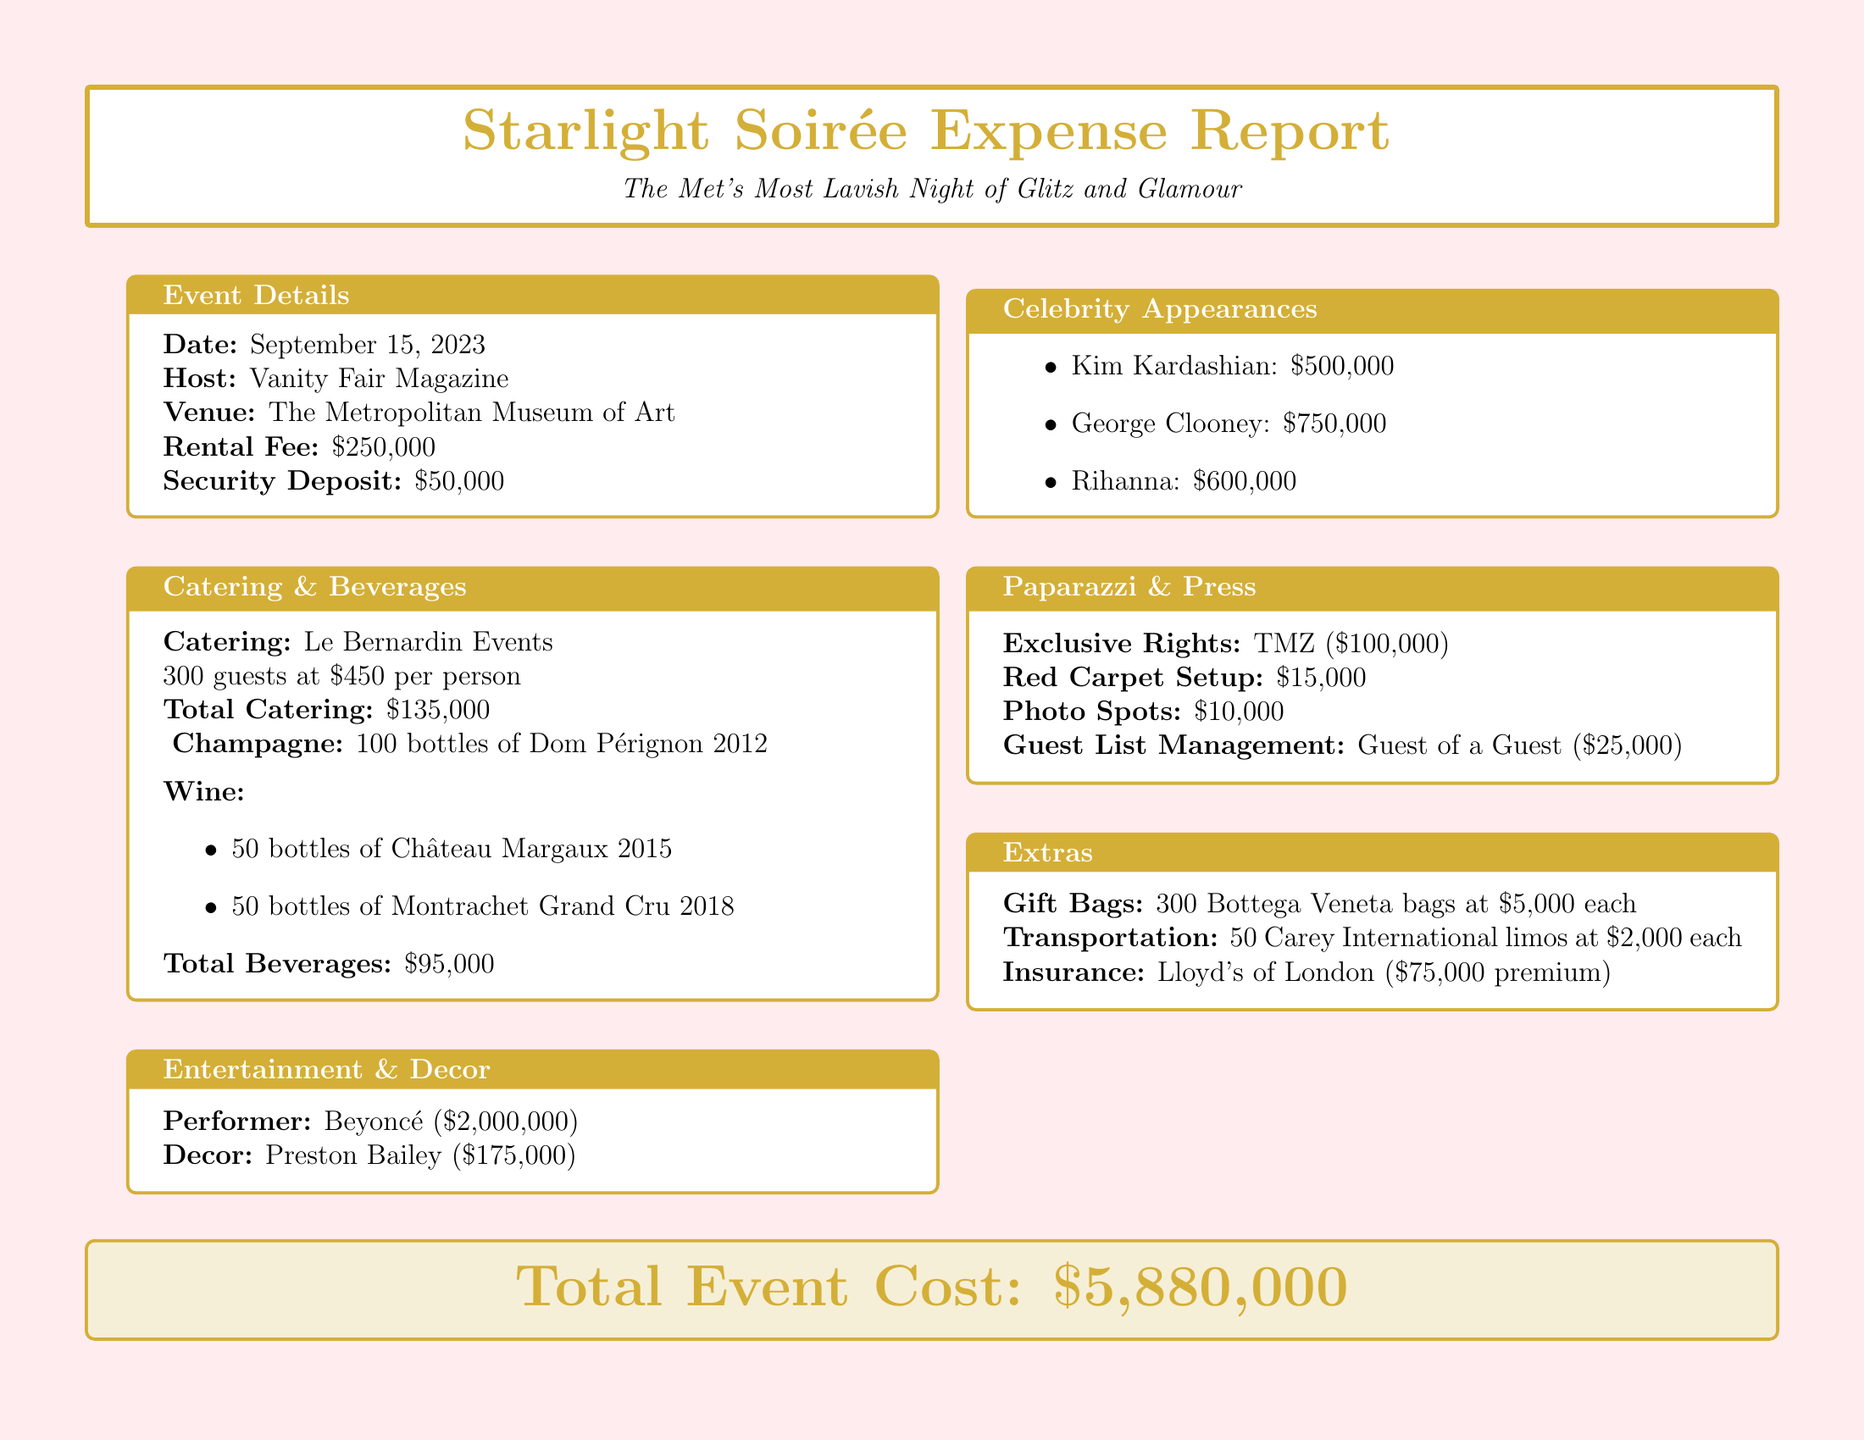what is the event name? The event name is stated clearly at the beginning of the document.
Answer: Starlight Soirée at The Met who hosted the event? The document explicitly mentions the host responsible for the event.
Answer: Vanity Fair Magazine how much was the rental fee for the venue? The document outlines the costs associated with the venue, including the rental fee.
Answer: 250000 what is the total cost of beverages? The total cost of beverages can be calculated by summing the costs listed in the beverages section.
Answer: 95000 who is the performer at the event? The performer's name is highlighted in the entertainment section of the document.
Answer: Beyoncé how much did Kim Kardashian charge for her appearance? The document includes a list of celebrity appearance fees, including Kim Kardashian's fee.
Answer: 500000 what is the total cost of gift bags? The total cost of gift bags is detailed in the "Extras" section, specifying the amount and items involved.
Answer: 1500000 how many guests were catered for? The number of guests catered for is specified in the catering section of the document.
Answer: 300 what is the total event cost? The total event cost is stated at the end of the document.
Answer: 5880000 